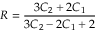<formula> <loc_0><loc_0><loc_500><loc_500>R = \frac { 3 C _ { 2 } + 2 C _ { 1 } } { 3 C _ { 2 } - 2 C _ { 1 } + 2 }</formula> 